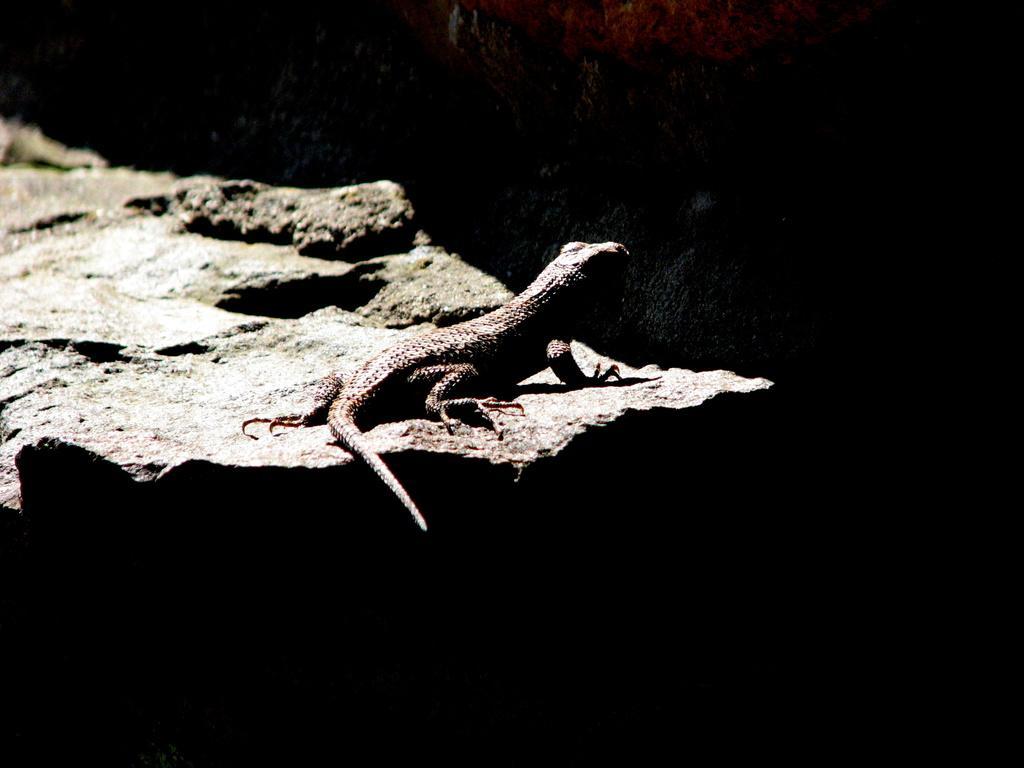In one or two sentences, can you explain what this image depicts? There is a lizard on a rock. And the background is dark in color. 